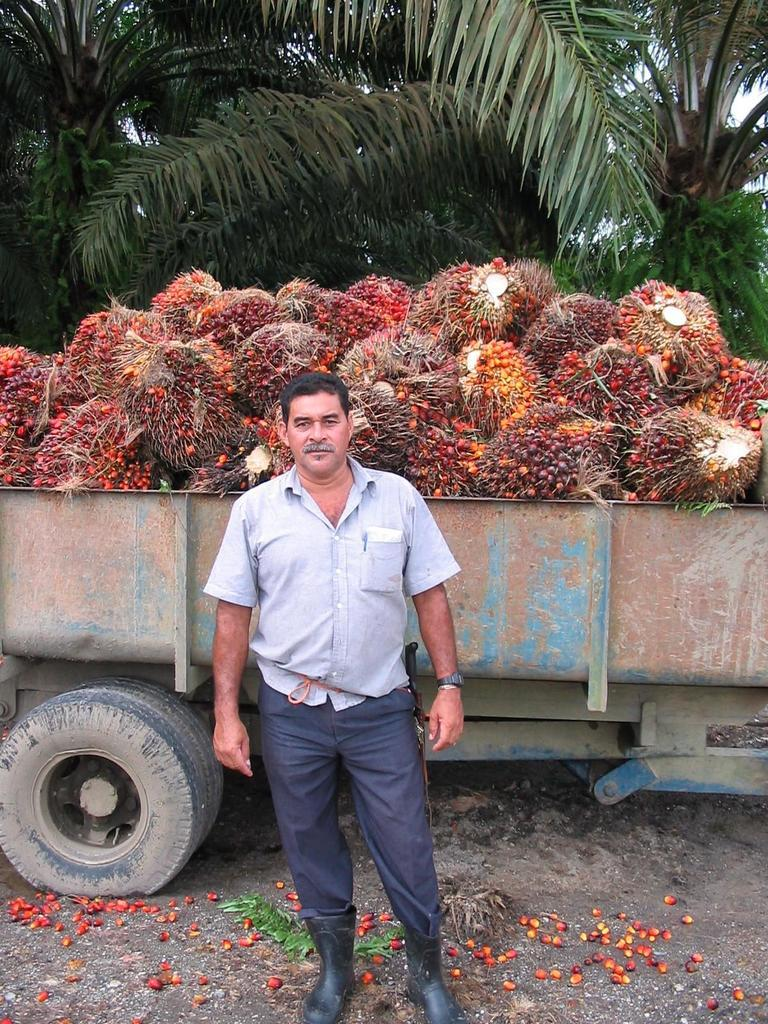What is the main subject in the image? There is a person standing in the image. What can be seen in the background of the image? There are trees visible in the background of the image. What is inside the vehicle in the image? There are fruits in a vehicle. What colors do the fruits have? The fruits have yellow, red, and orange colors. What type of quartz can be seen in the image? There is no quartz present in the image. Who is controlling the vehicle with the fruits in the image? The image does not show anyone controlling a vehicle; it only shows a person standing and fruits in a vehicle. 